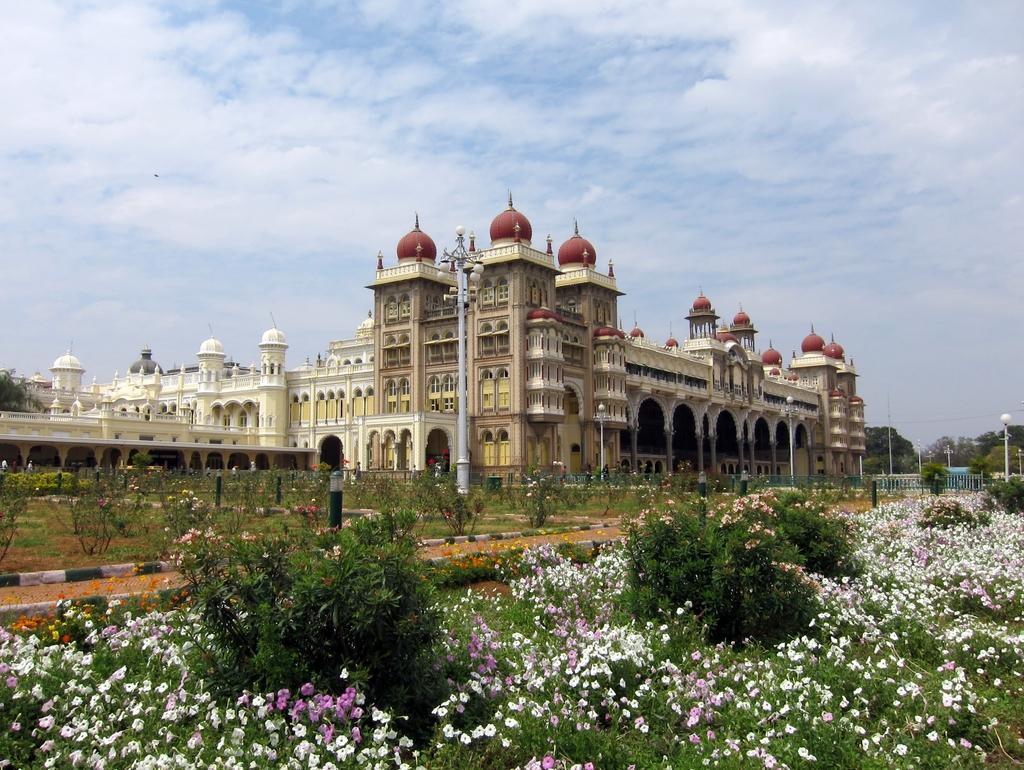How would you summarize this image in a sentence or two? In this image there is a building in-front of that there is a garden with so many flower plants and pole with some lights, behind the building there are some trees. 